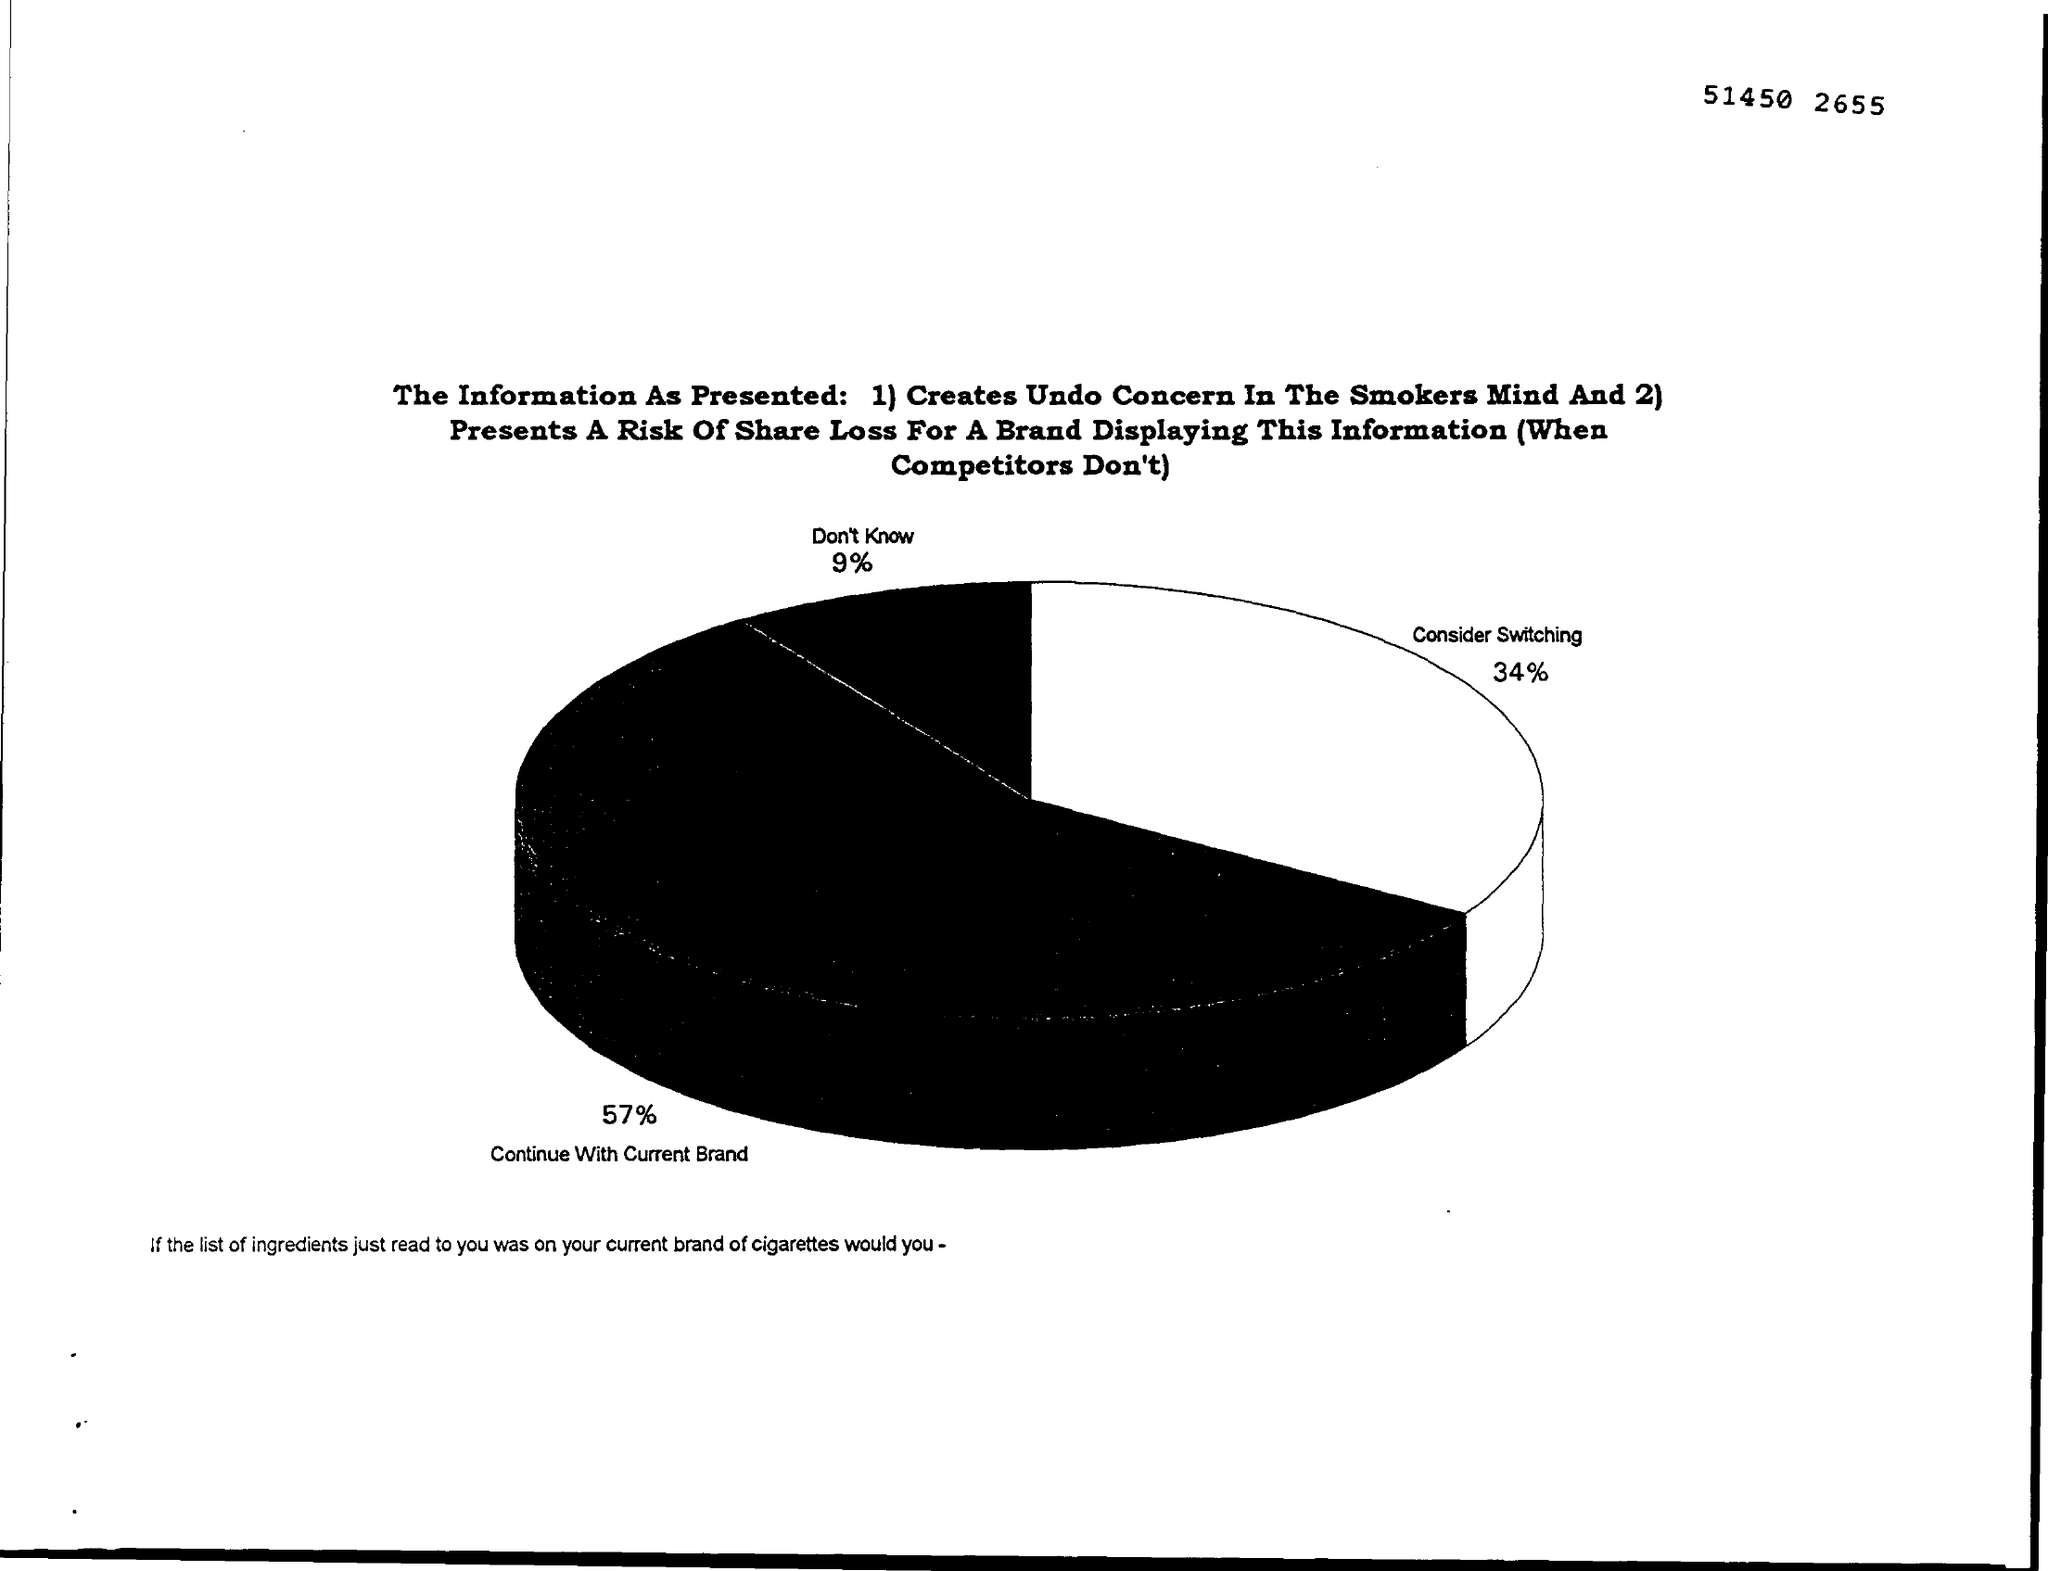Specify some key components in this picture. Thirty-four percent of respondents indicated that they are considering switching to another service for their hosting needs. According to the survey results, 57% of respondents want to continue with the current brand. 